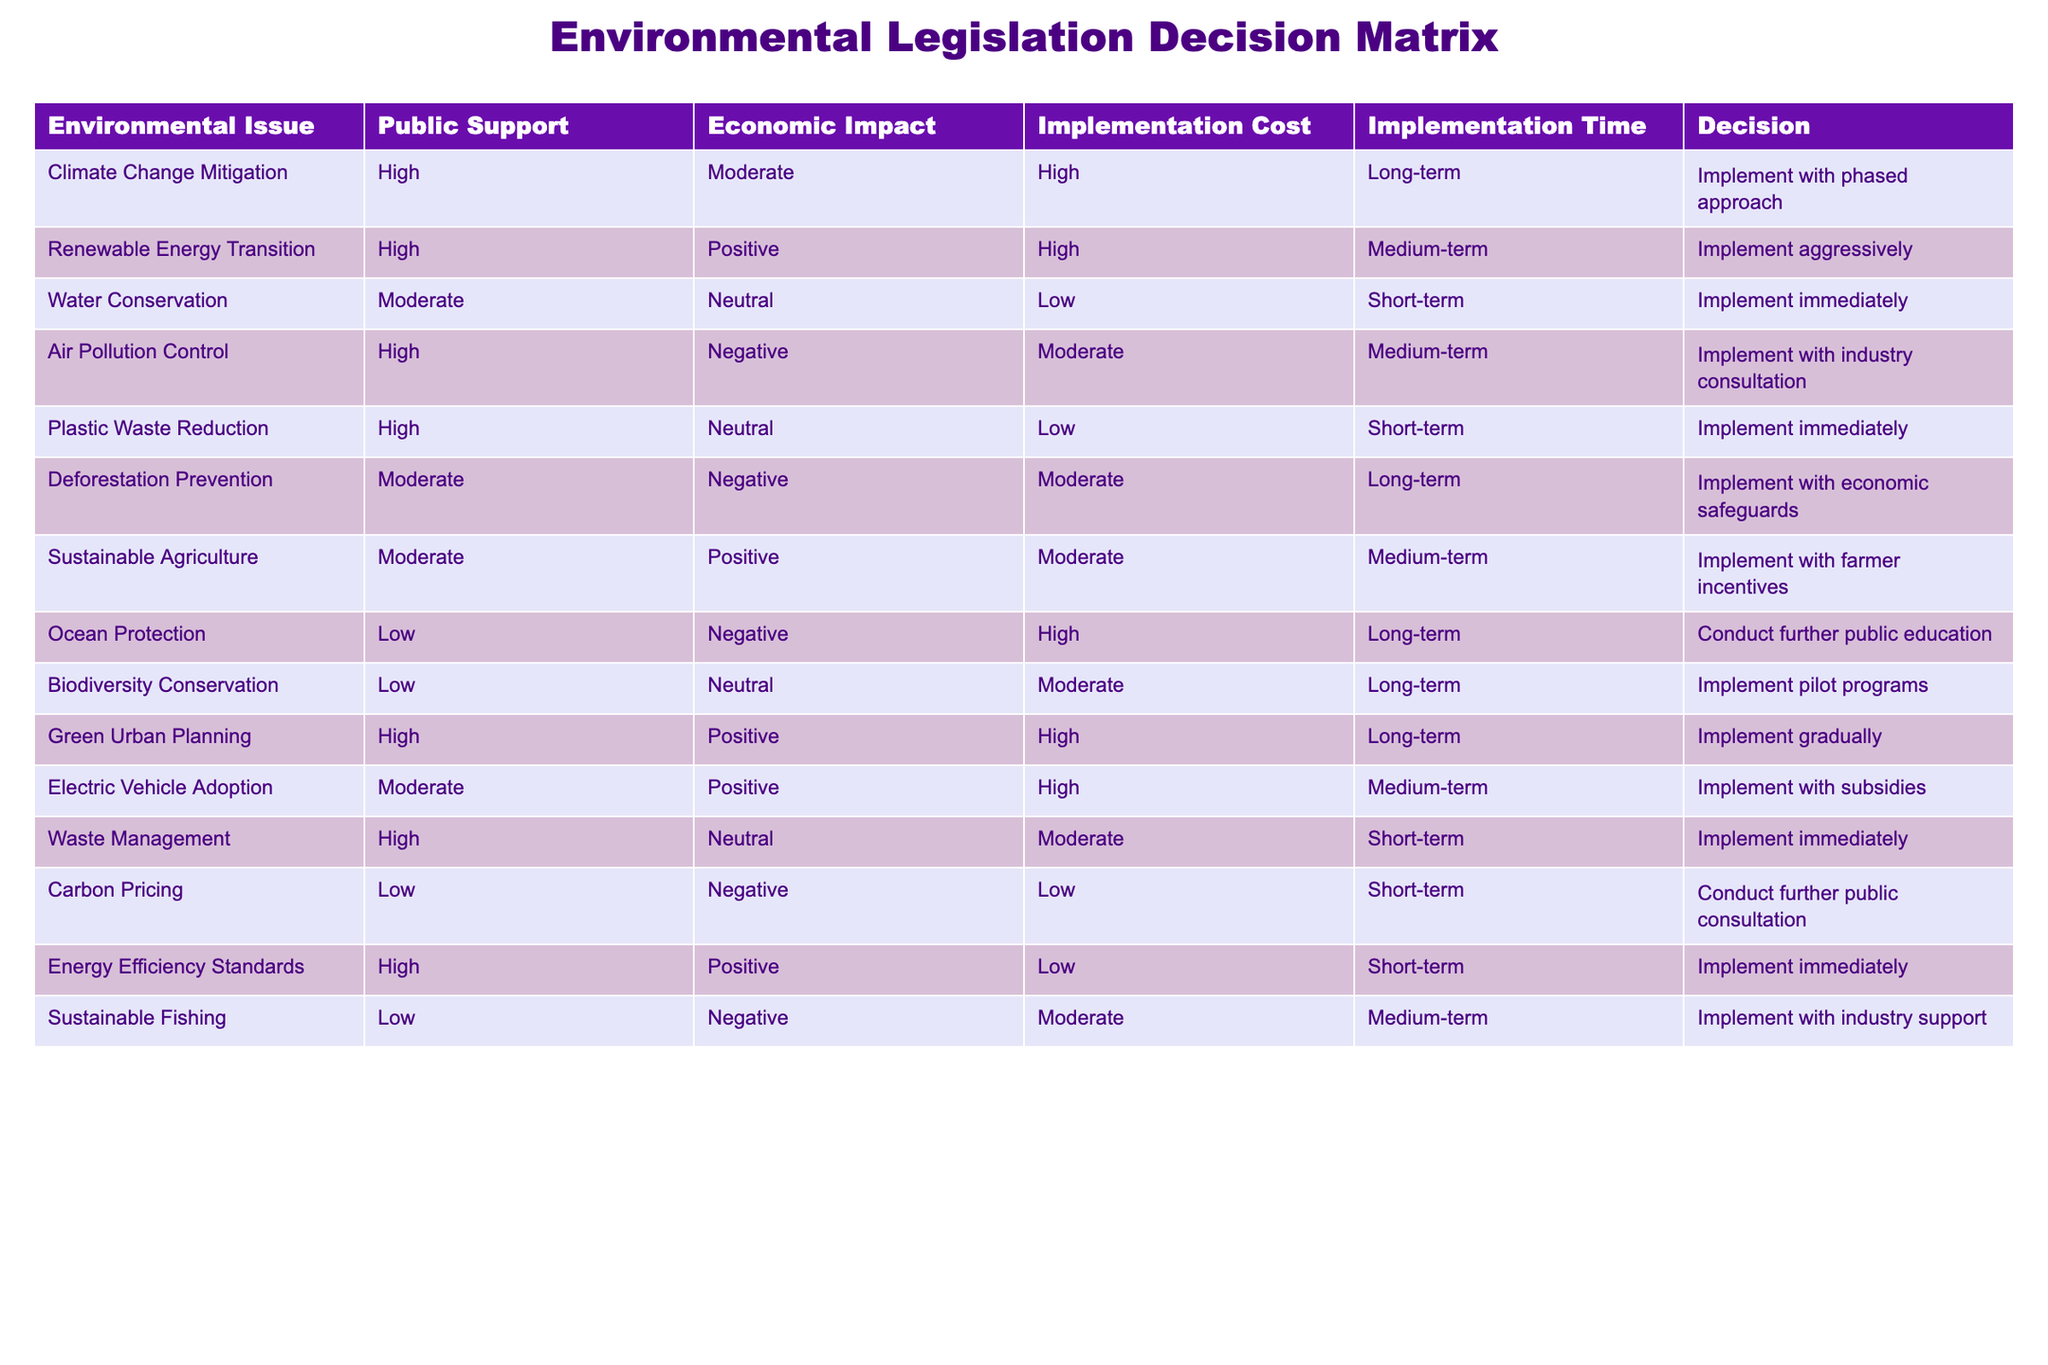What is the public support level for Climate Change Mitigation? According to the table, the public support level for Climate Change Mitigation is listed as "High".
Answer: High Which environmental issue has the lowest public support? The table indicates that Ocean Protection and Biodiversity Conservation both have "Low" public support.
Answer: Ocean Protection and Biodiversity Conservation What is the implementation cost for Renewable Energy Transition? The table shows that the implementation cost for Renewable Energy Transition is categorized as "High".
Answer: High How many environmental issues have a positive economic impact? By examining the table, Renewable Energy Transition, Sustainable Agriculture, and Energy Efficiency Standards are the three issues that have a "Positive" economic impact, giving a total of three.
Answer: Three Is it true that all environmental issues with high public support have a high implementation cost? The table shows that Climate Change Mitigation and Renewable Energy Transition have high implementation costs, but Waste Management and Plastic Waste Reduction both have low implementation costs despite having high public support. Thus, this statement is false.
Answer: False What is the average implementation cost of issues with high public support? The implementation costs of the high public support issues are: Climate Change Mitigation (High), Renewable Energy Transition (High), Air Pollution Control (Moderate), Plastic Waste Reduction (Low), Green Urban Planning (High), and Energy Efficiency Standards (Low). Converting these to a scale where High=3, Moderate=2, Low=1 gives: 3, 3, 2, 1, 3, 1; the sum is 13. Dividing by 6 items, the average cost is approximately 2.17, corresponding to Moderate.
Answer: Moderate Which environmental issue is recommended for immediate implementation and has a neutral economic impact? The table lists both Water Conservation and Waste Management as having a neutral economic impact and are recommended for immediate implementation.
Answer: Water Conservation and Waste Management What is the implementation time for Deforestation Prevention? According to the table, Deforestation Prevention is categorized as having a "Long-term" implementation time.
Answer: Long-term How many environmental issues have a burden on the economy? From the table, Climate Change Mitigation, Water Conservation, Plastic Waste Reduction, and others have either "Positive" or "Neutral" economic impacts, while Ocean Protection, Air Pollution Control, Deforestation Prevention, and Sustainable Fishing have "Negative" impacts, totaling four issues with economic burdens.
Answer: Four 